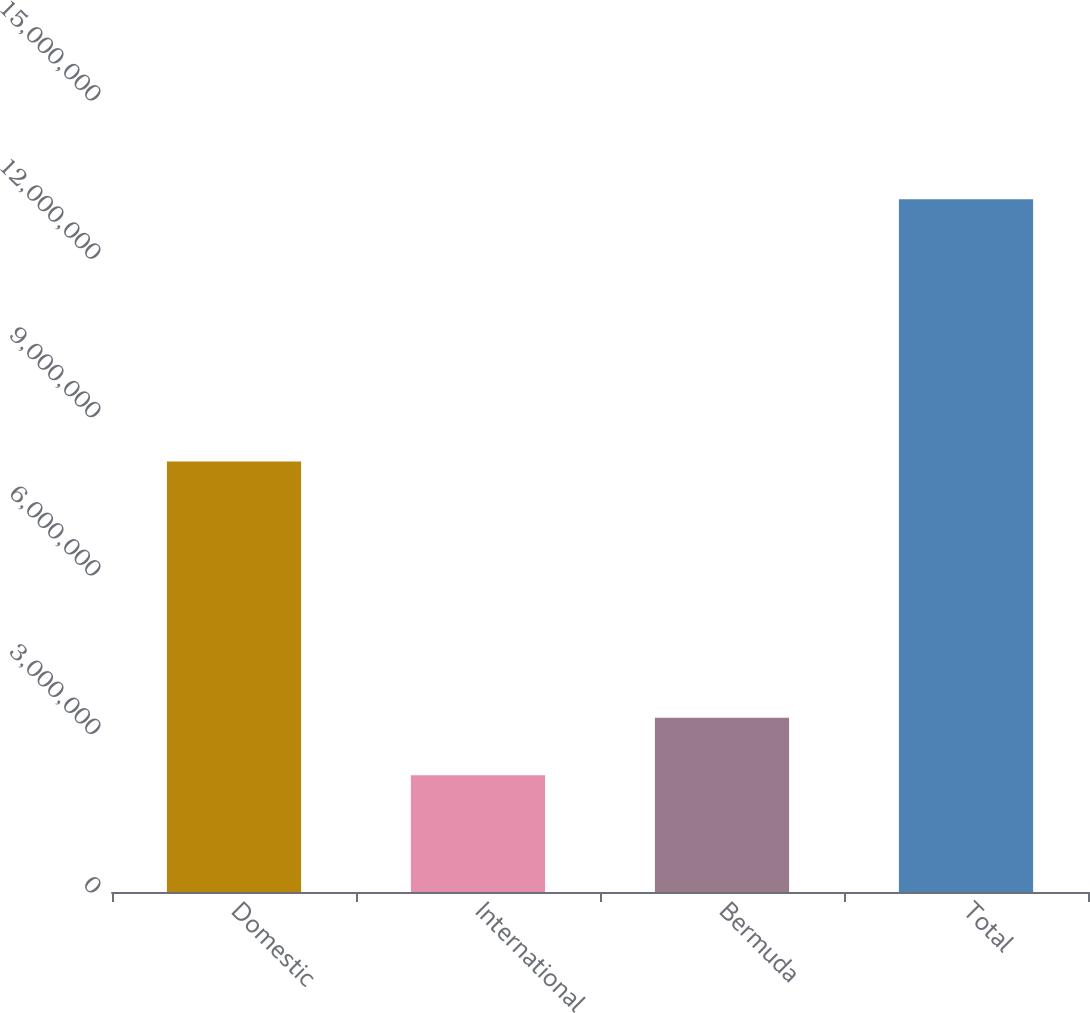Convert chart to OTSL. <chart><loc_0><loc_0><loc_500><loc_500><bar_chart><fcel>Domestic<fcel>International<fcel>Bermuda<fcel>Total<nl><fcel>8.154e+06<fcel>2.2092e+06<fcel>3.30019e+06<fcel>1.31191e+07<nl></chart> 